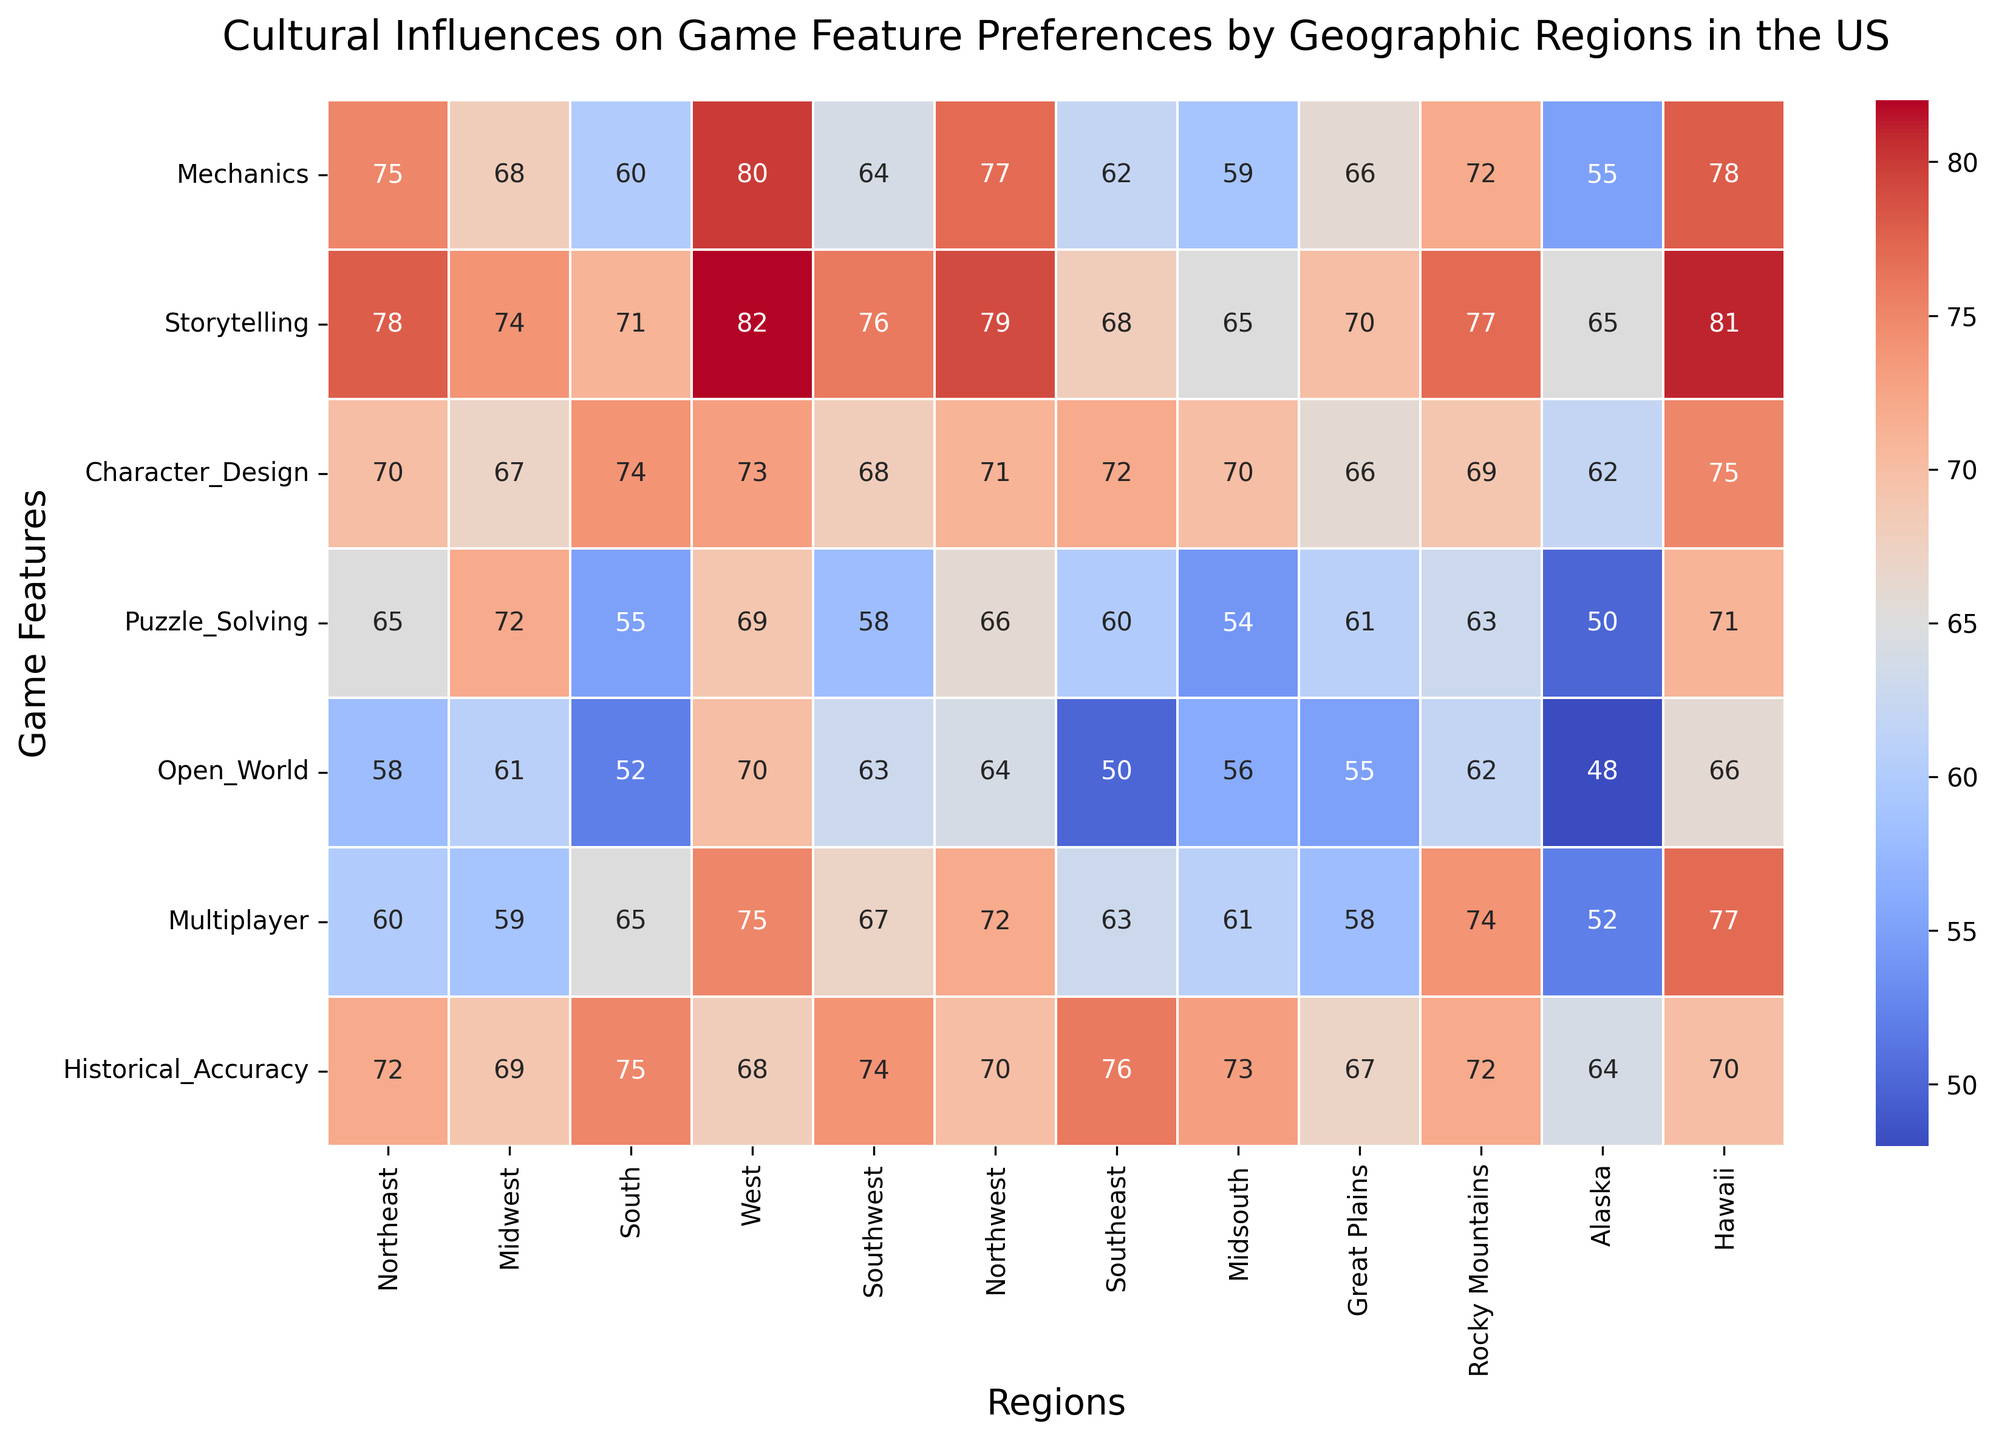Which region values Multiplayer the highest? Look at the column for Multiplayer; Hawaii has the highest value at 77.
Answer: Hawaii What is the difference in preference for Open World between the Northeast and the South? The Open World preference for the Northeast is 58 and for the South is 52. The difference is 58 - 52 = 6.
Answer: 6 Which region has the lowest preference for Historical Accuracy? Look at the column for Historical Accuracy; Alaska has the lowest value at 64.
Answer: Alaska What is the average preference score of Storytelling across all regions? Sum the Storytelling values (78 + 74 + 71 + 82 + 76 + 79 + 68 + 65 + 70 + 77 + 65 + 81) = 906. Then, divide by the number of regions, which is 12. 906 / 12 = 75.5
Answer: 75.5 Is the Mechanics preference higher in the West or the Northeast? The Mechanics preference in the West is 80 and in the Northeast is 75. 80 is greater than 75.
Answer: West Between the Southeast and Northwest, which region prefers Puzzle Solving more? The Puzzle Solving preference in the Southeast is 60 and in the Northwest is 66. 66 is greater than 60.
Answer: Northwest What is the median value for Character Design across all regions? List the Character Design values in ascending order (62, 66, 67, 68, 69, 70, 70, 71, 72, 73, 74, 75). There are 12 values. The middle two values are 70 and 71, so the median is the average of these two: (70 + 71) / 2 = 70.5
Answer: 70.5 How much higher is the Northeast's preference for Historical Accuracy compared to Mechanics? The preference for Historical Accuracy in the Northeast is 72 and for Mechanics is 75. The difference is 75 - 72 = 3.
Answer: 3 Which region most prefers Open World games? Look at the column for Open World; the West has the highest value at 70.
Answer: West 